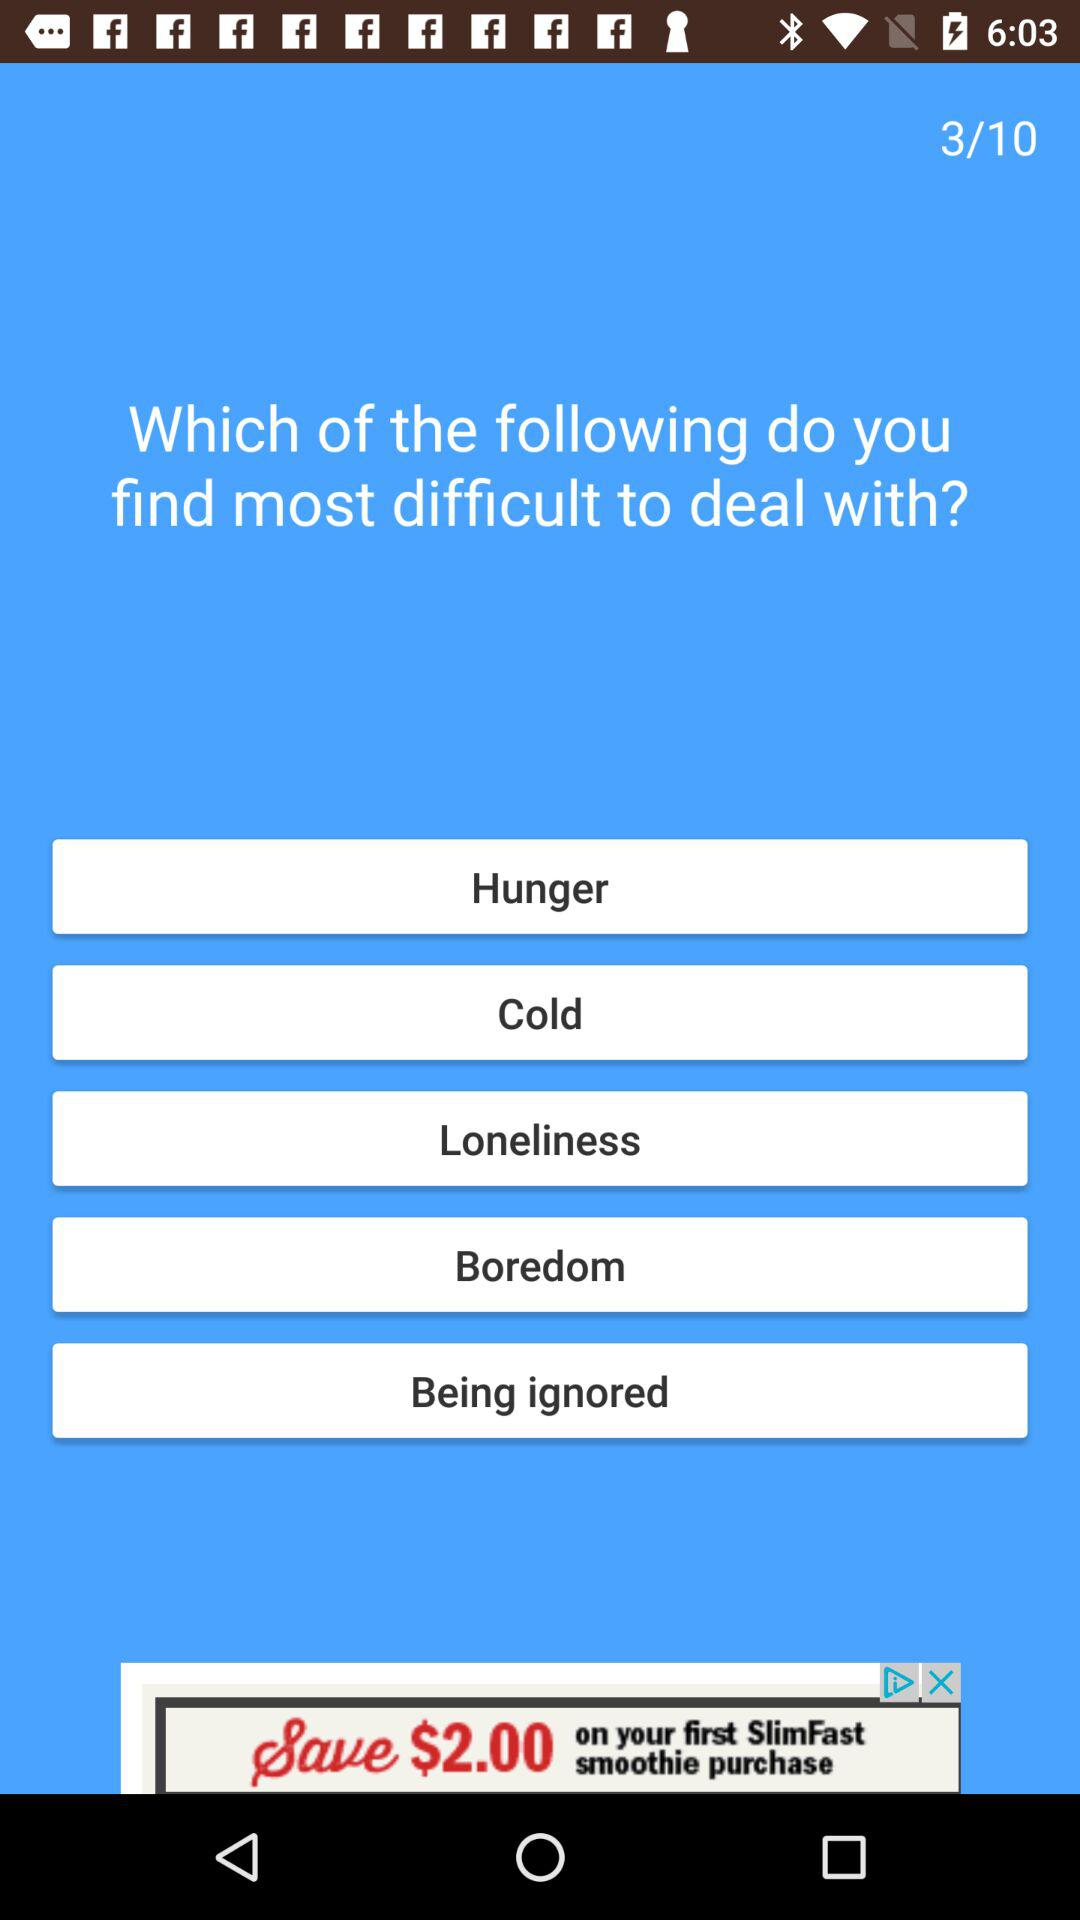What is the current question number? The current question number is 3. 